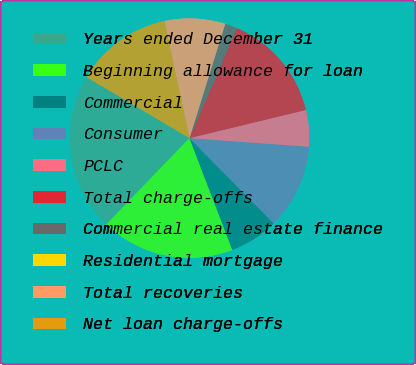<chart> <loc_0><loc_0><loc_500><loc_500><pie_chart><fcel>Years ended December 31<fcel>Beginning allowance for loan<fcel>Commercial<fcel>Consumer<fcel>PCLC<fcel>Total charge-offs<fcel>Commercial real estate finance<fcel>Residential mortgage<fcel>Total recoveries<fcel>Net loan charge-offs<nl><fcel>21.31%<fcel>18.03%<fcel>6.56%<fcel>11.47%<fcel>4.92%<fcel>14.75%<fcel>1.64%<fcel>0.0%<fcel>8.2%<fcel>13.11%<nl></chart> 